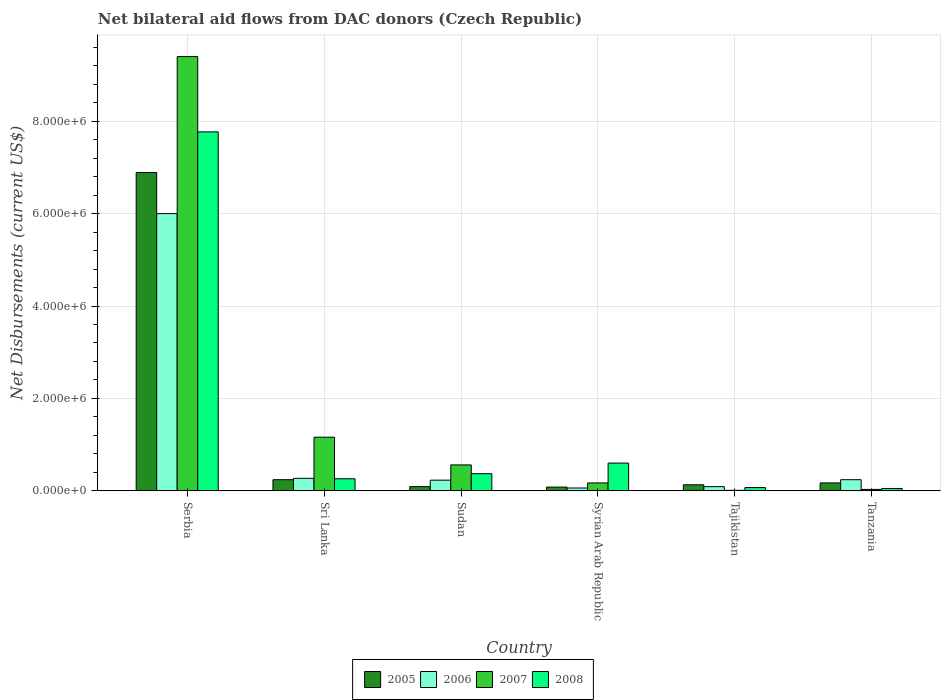Are the number of bars per tick equal to the number of legend labels?
Provide a succinct answer. Yes. How many bars are there on the 1st tick from the left?
Ensure brevity in your answer.  4. What is the label of the 6th group of bars from the left?
Ensure brevity in your answer.  Tanzania. In how many cases, is the number of bars for a given country not equal to the number of legend labels?
Your answer should be compact. 0. What is the net bilateral aid flows in 2005 in Sri Lanka?
Your answer should be very brief. 2.40e+05. In which country was the net bilateral aid flows in 2008 maximum?
Your response must be concise. Serbia. In which country was the net bilateral aid flows in 2006 minimum?
Your answer should be compact. Syrian Arab Republic. What is the total net bilateral aid flows in 2008 in the graph?
Your answer should be very brief. 9.12e+06. What is the difference between the net bilateral aid flows in 2008 in Sri Lanka and that in Tanzania?
Your answer should be very brief. 2.10e+05. What is the average net bilateral aid flows in 2005 per country?
Make the answer very short. 1.27e+06. What is the difference between the net bilateral aid flows of/in 2008 and net bilateral aid flows of/in 2005 in Syrian Arab Republic?
Your answer should be compact. 5.20e+05. Is the net bilateral aid flows in 2008 in Sri Lanka less than that in Syrian Arab Republic?
Make the answer very short. Yes. Is the difference between the net bilateral aid flows in 2008 in Sri Lanka and Tanzania greater than the difference between the net bilateral aid flows in 2005 in Sri Lanka and Tanzania?
Provide a succinct answer. Yes. What is the difference between the highest and the second highest net bilateral aid flows in 2007?
Make the answer very short. 8.24e+06. What is the difference between the highest and the lowest net bilateral aid flows in 2008?
Ensure brevity in your answer.  7.72e+06. Is it the case that in every country, the sum of the net bilateral aid flows in 2005 and net bilateral aid flows in 2007 is greater than the sum of net bilateral aid flows in 2008 and net bilateral aid flows in 2006?
Your answer should be very brief. No. What does the 3rd bar from the left in Sri Lanka represents?
Keep it short and to the point. 2007. What does the 3rd bar from the right in Tanzania represents?
Make the answer very short. 2006. Is it the case that in every country, the sum of the net bilateral aid flows in 2005 and net bilateral aid flows in 2008 is greater than the net bilateral aid flows in 2007?
Provide a short and direct response. No. How many bars are there?
Your response must be concise. 24. How many countries are there in the graph?
Give a very brief answer. 6. Are the values on the major ticks of Y-axis written in scientific E-notation?
Keep it short and to the point. Yes. Where does the legend appear in the graph?
Provide a short and direct response. Bottom center. How many legend labels are there?
Provide a short and direct response. 4. How are the legend labels stacked?
Provide a succinct answer. Horizontal. What is the title of the graph?
Offer a terse response. Net bilateral aid flows from DAC donors (Czech Republic). What is the label or title of the X-axis?
Offer a very short reply. Country. What is the label or title of the Y-axis?
Your answer should be compact. Net Disbursements (current US$). What is the Net Disbursements (current US$) of 2005 in Serbia?
Your answer should be very brief. 6.89e+06. What is the Net Disbursements (current US$) in 2006 in Serbia?
Ensure brevity in your answer.  6.00e+06. What is the Net Disbursements (current US$) in 2007 in Serbia?
Offer a very short reply. 9.40e+06. What is the Net Disbursements (current US$) of 2008 in Serbia?
Make the answer very short. 7.77e+06. What is the Net Disbursements (current US$) in 2005 in Sri Lanka?
Give a very brief answer. 2.40e+05. What is the Net Disbursements (current US$) in 2007 in Sri Lanka?
Provide a short and direct response. 1.16e+06. What is the Net Disbursements (current US$) of 2008 in Sri Lanka?
Ensure brevity in your answer.  2.60e+05. What is the Net Disbursements (current US$) in 2005 in Sudan?
Your answer should be very brief. 9.00e+04. What is the Net Disbursements (current US$) in 2007 in Sudan?
Your response must be concise. 5.60e+05. What is the Net Disbursements (current US$) of 2008 in Syrian Arab Republic?
Your response must be concise. 6.00e+05. What is the Net Disbursements (current US$) of 2006 in Tajikistan?
Give a very brief answer. 9.00e+04. What is the Net Disbursements (current US$) of 2007 in Tajikistan?
Provide a succinct answer. 10000. What is the Net Disbursements (current US$) of 2008 in Tajikistan?
Your answer should be compact. 7.00e+04. What is the Net Disbursements (current US$) of 2005 in Tanzania?
Your answer should be very brief. 1.70e+05. What is the Net Disbursements (current US$) of 2007 in Tanzania?
Offer a terse response. 3.00e+04. What is the Net Disbursements (current US$) of 2008 in Tanzania?
Your answer should be compact. 5.00e+04. Across all countries, what is the maximum Net Disbursements (current US$) in 2005?
Ensure brevity in your answer.  6.89e+06. Across all countries, what is the maximum Net Disbursements (current US$) of 2007?
Offer a very short reply. 9.40e+06. Across all countries, what is the maximum Net Disbursements (current US$) in 2008?
Your answer should be compact. 7.77e+06. Across all countries, what is the minimum Net Disbursements (current US$) in 2005?
Ensure brevity in your answer.  8.00e+04. What is the total Net Disbursements (current US$) of 2005 in the graph?
Provide a short and direct response. 7.60e+06. What is the total Net Disbursements (current US$) in 2006 in the graph?
Ensure brevity in your answer.  6.89e+06. What is the total Net Disbursements (current US$) of 2007 in the graph?
Keep it short and to the point. 1.13e+07. What is the total Net Disbursements (current US$) of 2008 in the graph?
Offer a very short reply. 9.12e+06. What is the difference between the Net Disbursements (current US$) in 2005 in Serbia and that in Sri Lanka?
Offer a very short reply. 6.65e+06. What is the difference between the Net Disbursements (current US$) in 2006 in Serbia and that in Sri Lanka?
Provide a succinct answer. 5.73e+06. What is the difference between the Net Disbursements (current US$) of 2007 in Serbia and that in Sri Lanka?
Keep it short and to the point. 8.24e+06. What is the difference between the Net Disbursements (current US$) in 2008 in Serbia and that in Sri Lanka?
Provide a succinct answer. 7.51e+06. What is the difference between the Net Disbursements (current US$) of 2005 in Serbia and that in Sudan?
Keep it short and to the point. 6.80e+06. What is the difference between the Net Disbursements (current US$) of 2006 in Serbia and that in Sudan?
Your answer should be compact. 5.77e+06. What is the difference between the Net Disbursements (current US$) of 2007 in Serbia and that in Sudan?
Ensure brevity in your answer.  8.84e+06. What is the difference between the Net Disbursements (current US$) in 2008 in Serbia and that in Sudan?
Provide a succinct answer. 7.40e+06. What is the difference between the Net Disbursements (current US$) in 2005 in Serbia and that in Syrian Arab Republic?
Your answer should be compact. 6.81e+06. What is the difference between the Net Disbursements (current US$) in 2006 in Serbia and that in Syrian Arab Republic?
Provide a short and direct response. 5.94e+06. What is the difference between the Net Disbursements (current US$) of 2007 in Serbia and that in Syrian Arab Republic?
Ensure brevity in your answer.  9.23e+06. What is the difference between the Net Disbursements (current US$) in 2008 in Serbia and that in Syrian Arab Republic?
Provide a short and direct response. 7.17e+06. What is the difference between the Net Disbursements (current US$) in 2005 in Serbia and that in Tajikistan?
Give a very brief answer. 6.76e+06. What is the difference between the Net Disbursements (current US$) in 2006 in Serbia and that in Tajikistan?
Your response must be concise. 5.91e+06. What is the difference between the Net Disbursements (current US$) of 2007 in Serbia and that in Tajikistan?
Offer a very short reply. 9.39e+06. What is the difference between the Net Disbursements (current US$) of 2008 in Serbia and that in Tajikistan?
Keep it short and to the point. 7.70e+06. What is the difference between the Net Disbursements (current US$) in 2005 in Serbia and that in Tanzania?
Offer a very short reply. 6.72e+06. What is the difference between the Net Disbursements (current US$) in 2006 in Serbia and that in Tanzania?
Your answer should be compact. 5.76e+06. What is the difference between the Net Disbursements (current US$) in 2007 in Serbia and that in Tanzania?
Provide a succinct answer. 9.37e+06. What is the difference between the Net Disbursements (current US$) in 2008 in Serbia and that in Tanzania?
Offer a terse response. 7.72e+06. What is the difference between the Net Disbursements (current US$) of 2006 in Sri Lanka and that in Sudan?
Make the answer very short. 4.00e+04. What is the difference between the Net Disbursements (current US$) in 2007 in Sri Lanka and that in Sudan?
Your answer should be very brief. 6.00e+05. What is the difference between the Net Disbursements (current US$) of 2005 in Sri Lanka and that in Syrian Arab Republic?
Provide a short and direct response. 1.60e+05. What is the difference between the Net Disbursements (current US$) of 2007 in Sri Lanka and that in Syrian Arab Republic?
Give a very brief answer. 9.90e+05. What is the difference between the Net Disbursements (current US$) in 2008 in Sri Lanka and that in Syrian Arab Republic?
Offer a terse response. -3.40e+05. What is the difference between the Net Disbursements (current US$) in 2007 in Sri Lanka and that in Tajikistan?
Offer a terse response. 1.15e+06. What is the difference between the Net Disbursements (current US$) of 2006 in Sri Lanka and that in Tanzania?
Your answer should be compact. 3.00e+04. What is the difference between the Net Disbursements (current US$) in 2007 in Sri Lanka and that in Tanzania?
Keep it short and to the point. 1.13e+06. What is the difference between the Net Disbursements (current US$) of 2007 in Sudan and that in Syrian Arab Republic?
Provide a succinct answer. 3.90e+05. What is the difference between the Net Disbursements (current US$) of 2006 in Sudan and that in Tajikistan?
Provide a succinct answer. 1.40e+05. What is the difference between the Net Disbursements (current US$) of 2007 in Sudan and that in Tajikistan?
Your answer should be compact. 5.50e+05. What is the difference between the Net Disbursements (current US$) of 2008 in Sudan and that in Tajikistan?
Offer a terse response. 3.00e+05. What is the difference between the Net Disbursements (current US$) of 2005 in Sudan and that in Tanzania?
Offer a very short reply. -8.00e+04. What is the difference between the Net Disbursements (current US$) of 2006 in Sudan and that in Tanzania?
Keep it short and to the point. -10000. What is the difference between the Net Disbursements (current US$) in 2007 in Sudan and that in Tanzania?
Provide a short and direct response. 5.30e+05. What is the difference between the Net Disbursements (current US$) of 2005 in Syrian Arab Republic and that in Tajikistan?
Your response must be concise. -5.00e+04. What is the difference between the Net Disbursements (current US$) in 2006 in Syrian Arab Republic and that in Tajikistan?
Your response must be concise. -3.00e+04. What is the difference between the Net Disbursements (current US$) in 2007 in Syrian Arab Republic and that in Tajikistan?
Your response must be concise. 1.60e+05. What is the difference between the Net Disbursements (current US$) in 2008 in Syrian Arab Republic and that in Tajikistan?
Ensure brevity in your answer.  5.30e+05. What is the difference between the Net Disbursements (current US$) in 2006 in Syrian Arab Republic and that in Tanzania?
Your answer should be compact. -1.80e+05. What is the difference between the Net Disbursements (current US$) of 2007 in Syrian Arab Republic and that in Tanzania?
Your response must be concise. 1.40e+05. What is the difference between the Net Disbursements (current US$) of 2005 in Tajikistan and that in Tanzania?
Offer a very short reply. -4.00e+04. What is the difference between the Net Disbursements (current US$) in 2008 in Tajikistan and that in Tanzania?
Your response must be concise. 2.00e+04. What is the difference between the Net Disbursements (current US$) of 2005 in Serbia and the Net Disbursements (current US$) of 2006 in Sri Lanka?
Ensure brevity in your answer.  6.62e+06. What is the difference between the Net Disbursements (current US$) of 2005 in Serbia and the Net Disbursements (current US$) of 2007 in Sri Lanka?
Your response must be concise. 5.73e+06. What is the difference between the Net Disbursements (current US$) in 2005 in Serbia and the Net Disbursements (current US$) in 2008 in Sri Lanka?
Offer a very short reply. 6.63e+06. What is the difference between the Net Disbursements (current US$) in 2006 in Serbia and the Net Disbursements (current US$) in 2007 in Sri Lanka?
Offer a terse response. 4.84e+06. What is the difference between the Net Disbursements (current US$) of 2006 in Serbia and the Net Disbursements (current US$) of 2008 in Sri Lanka?
Offer a very short reply. 5.74e+06. What is the difference between the Net Disbursements (current US$) of 2007 in Serbia and the Net Disbursements (current US$) of 2008 in Sri Lanka?
Offer a terse response. 9.14e+06. What is the difference between the Net Disbursements (current US$) in 2005 in Serbia and the Net Disbursements (current US$) in 2006 in Sudan?
Your answer should be compact. 6.66e+06. What is the difference between the Net Disbursements (current US$) in 2005 in Serbia and the Net Disbursements (current US$) in 2007 in Sudan?
Ensure brevity in your answer.  6.33e+06. What is the difference between the Net Disbursements (current US$) of 2005 in Serbia and the Net Disbursements (current US$) of 2008 in Sudan?
Your answer should be compact. 6.52e+06. What is the difference between the Net Disbursements (current US$) in 2006 in Serbia and the Net Disbursements (current US$) in 2007 in Sudan?
Provide a short and direct response. 5.44e+06. What is the difference between the Net Disbursements (current US$) of 2006 in Serbia and the Net Disbursements (current US$) of 2008 in Sudan?
Offer a very short reply. 5.63e+06. What is the difference between the Net Disbursements (current US$) of 2007 in Serbia and the Net Disbursements (current US$) of 2008 in Sudan?
Ensure brevity in your answer.  9.03e+06. What is the difference between the Net Disbursements (current US$) in 2005 in Serbia and the Net Disbursements (current US$) in 2006 in Syrian Arab Republic?
Make the answer very short. 6.83e+06. What is the difference between the Net Disbursements (current US$) of 2005 in Serbia and the Net Disbursements (current US$) of 2007 in Syrian Arab Republic?
Your answer should be compact. 6.72e+06. What is the difference between the Net Disbursements (current US$) in 2005 in Serbia and the Net Disbursements (current US$) in 2008 in Syrian Arab Republic?
Keep it short and to the point. 6.29e+06. What is the difference between the Net Disbursements (current US$) in 2006 in Serbia and the Net Disbursements (current US$) in 2007 in Syrian Arab Republic?
Ensure brevity in your answer.  5.83e+06. What is the difference between the Net Disbursements (current US$) of 2006 in Serbia and the Net Disbursements (current US$) of 2008 in Syrian Arab Republic?
Provide a short and direct response. 5.40e+06. What is the difference between the Net Disbursements (current US$) in 2007 in Serbia and the Net Disbursements (current US$) in 2008 in Syrian Arab Republic?
Provide a succinct answer. 8.80e+06. What is the difference between the Net Disbursements (current US$) of 2005 in Serbia and the Net Disbursements (current US$) of 2006 in Tajikistan?
Your answer should be very brief. 6.80e+06. What is the difference between the Net Disbursements (current US$) in 2005 in Serbia and the Net Disbursements (current US$) in 2007 in Tajikistan?
Offer a very short reply. 6.88e+06. What is the difference between the Net Disbursements (current US$) in 2005 in Serbia and the Net Disbursements (current US$) in 2008 in Tajikistan?
Make the answer very short. 6.82e+06. What is the difference between the Net Disbursements (current US$) in 2006 in Serbia and the Net Disbursements (current US$) in 2007 in Tajikistan?
Provide a succinct answer. 5.99e+06. What is the difference between the Net Disbursements (current US$) in 2006 in Serbia and the Net Disbursements (current US$) in 2008 in Tajikistan?
Your response must be concise. 5.93e+06. What is the difference between the Net Disbursements (current US$) of 2007 in Serbia and the Net Disbursements (current US$) of 2008 in Tajikistan?
Keep it short and to the point. 9.33e+06. What is the difference between the Net Disbursements (current US$) of 2005 in Serbia and the Net Disbursements (current US$) of 2006 in Tanzania?
Give a very brief answer. 6.65e+06. What is the difference between the Net Disbursements (current US$) of 2005 in Serbia and the Net Disbursements (current US$) of 2007 in Tanzania?
Your answer should be very brief. 6.86e+06. What is the difference between the Net Disbursements (current US$) of 2005 in Serbia and the Net Disbursements (current US$) of 2008 in Tanzania?
Keep it short and to the point. 6.84e+06. What is the difference between the Net Disbursements (current US$) in 2006 in Serbia and the Net Disbursements (current US$) in 2007 in Tanzania?
Give a very brief answer. 5.97e+06. What is the difference between the Net Disbursements (current US$) of 2006 in Serbia and the Net Disbursements (current US$) of 2008 in Tanzania?
Keep it short and to the point. 5.95e+06. What is the difference between the Net Disbursements (current US$) of 2007 in Serbia and the Net Disbursements (current US$) of 2008 in Tanzania?
Your response must be concise. 9.35e+06. What is the difference between the Net Disbursements (current US$) in 2005 in Sri Lanka and the Net Disbursements (current US$) in 2007 in Sudan?
Provide a short and direct response. -3.20e+05. What is the difference between the Net Disbursements (current US$) of 2006 in Sri Lanka and the Net Disbursements (current US$) of 2007 in Sudan?
Offer a very short reply. -2.90e+05. What is the difference between the Net Disbursements (current US$) of 2006 in Sri Lanka and the Net Disbursements (current US$) of 2008 in Sudan?
Ensure brevity in your answer.  -1.00e+05. What is the difference between the Net Disbursements (current US$) in 2007 in Sri Lanka and the Net Disbursements (current US$) in 2008 in Sudan?
Your response must be concise. 7.90e+05. What is the difference between the Net Disbursements (current US$) in 2005 in Sri Lanka and the Net Disbursements (current US$) in 2006 in Syrian Arab Republic?
Provide a short and direct response. 1.80e+05. What is the difference between the Net Disbursements (current US$) of 2005 in Sri Lanka and the Net Disbursements (current US$) of 2007 in Syrian Arab Republic?
Keep it short and to the point. 7.00e+04. What is the difference between the Net Disbursements (current US$) of 2005 in Sri Lanka and the Net Disbursements (current US$) of 2008 in Syrian Arab Republic?
Keep it short and to the point. -3.60e+05. What is the difference between the Net Disbursements (current US$) in 2006 in Sri Lanka and the Net Disbursements (current US$) in 2008 in Syrian Arab Republic?
Provide a succinct answer. -3.30e+05. What is the difference between the Net Disbursements (current US$) in 2007 in Sri Lanka and the Net Disbursements (current US$) in 2008 in Syrian Arab Republic?
Make the answer very short. 5.60e+05. What is the difference between the Net Disbursements (current US$) of 2005 in Sri Lanka and the Net Disbursements (current US$) of 2006 in Tajikistan?
Keep it short and to the point. 1.50e+05. What is the difference between the Net Disbursements (current US$) of 2005 in Sri Lanka and the Net Disbursements (current US$) of 2007 in Tajikistan?
Your response must be concise. 2.30e+05. What is the difference between the Net Disbursements (current US$) of 2005 in Sri Lanka and the Net Disbursements (current US$) of 2008 in Tajikistan?
Your answer should be very brief. 1.70e+05. What is the difference between the Net Disbursements (current US$) of 2007 in Sri Lanka and the Net Disbursements (current US$) of 2008 in Tajikistan?
Ensure brevity in your answer.  1.09e+06. What is the difference between the Net Disbursements (current US$) of 2006 in Sri Lanka and the Net Disbursements (current US$) of 2008 in Tanzania?
Give a very brief answer. 2.20e+05. What is the difference between the Net Disbursements (current US$) of 2007 in Sri Lanka and the Net Disbursements (current US$) of 2008 in Tanzania?
Keep it short and to the point. 1.11e+06. What is the difference between the Net Disbursements (current US$) of 2005 in Sudan and the Net Disbursements (current US$) of 2006 in Syrian Arab Republic?
Make the answer very short. 3.00e+04. What is the difference between the Net Disbursements (current US$) in 2005 in Sudan and the Net Disbursements (current US$) in 2008 in Syrian Arab Republic?
Make the answer very short. -5.10e+05. What is the difference between the Net Disbursements (current US$) of 2006 in Sudan and the Net Disbursements (current US$) of 2007 in Syrian Arab Republic?
Provide a short and direct response. 6.00e+04. What is the difference between the Net Disbursements (current US$) of 2006 in Sudan and the Net Disbursements (current US$) of 2008 in Syrian Arab Republic?
Ensure brevity in your answer.  -3.70e+05. What is the difference between the Net Disbursements (current US$) in 2007 in Sudan and the Net Disbursements (current US$) in 2008 in Syrian Arab Republic?
Keep it short and to the point. -4.00e+04. What is the difference between the Net Disbursements (current US$) of 2005 in Sudan and the Net Disbursements (current US$) of 2007 in Tajikistan?
Offer a terse response. 8.00e+04. What is the difference between the Net Disbursements (current US$) of 2005 in Sudan and the Net Disbursements (current US$) of 2008 in Tajikistan?
Give a very brief answer. 2.00e+04. What is the difference between the Net Disbursements (current US$) in 2006 in Sudan and the Net Disbursements (current US$) in 2007 in Tajikistan?
Offer a very short reply. 2.20e+05. What is the difference between the Net Disbursements (current US$) of 2007 in Sudan and the Net Disbursements (current US$) of 2008 in Tajikistan?
Your answer should be very brief. 4.90e+05. What is the difference between the Net Disbursements (current US$) of 2005 in Sudan and the Net Disbursements (current US$) of 2007 in Tanzania?
Offer a terse response. 6.00e+04. What is the difference between the Net Disbursements (current US$) in 2005 in Sudan and the Net Disbursements (current US$) in 2008 in Tanzania?
Provide a succinct answer. 4.00e+04. What is the difference between the Net Disbursements (current US$) of 2006 in Sudan and the Net Disbursements (current US$) of 2007 in Tanzania?
Provide a succinct answer. 2.00e+05. What is the difference between the Net Disbursements (current US$) of 2006 in Sudan and the Net Disbursements (current US$) of 2008 in Tanzania?
Your response must be concise. 1.80e+05. What is the difference between the Net Disbursements (current US$) of 2007 in Sudan and the Net Disbursements (current US$) of 2008 in Tanzania?
Offer a terse response. 5.10e+05. What is the difference between the Net Disbursements (current US$) of 2005 in Syrian Arab Republic and the Net Disbursements (current US$) of 2007 in Tajikistan?
Offer a terse response. 7.00e+04. What is the difference between the Net Disbursements (current US$) in 2005 in Syrian Arab Republic and the Net Disbursements (current US$) in 2008 in Tajikistan?
Provide a short and direct response. 10000. What is the difference between the Net Disbursements (current US$) of 2006 in Syrian Arab Republic and the Net Disbursements (current US$) of 2007 in Tajikistan?
Your response must be concise. 5.00e+04. What is the difference between the Net Disbursements (current US$) in 2005 in Syrian Arab Republic and the Net Disbursements (current US$) in 2006 in Tanzania?
Make the answer very short. -1.60e+05. What is the difference between the Net Disbursements (current US$) in 2005 in Syrian Arab Republic and the Net Disbursements (current US$) in 2008 in Tanzania?
Your answer should be very brief. 3.00e+04. What is the difference between the Net Disbursements (current US$) of 2006 in Syrian Arab Republic and the Net Disbursements (current US$) of 2007 in Tanzania?
Keep it short and to the point. 3.00e+04. What is the difference between the Net Disbursements (current US$) of 2006 in Syrian Arab Republic and the Net Disbursements (current US$) of 2008 in Tanzania?
Keep it short and to the point. 10000. What is the difference between the Net Disbursements (current US$) of 2005 in Tajikistan and the Net Disbursements (current US$) of 2008 in Tanzania?
Provide a short and direct response. 8.00e+04. What is the difference between the Net Disbursements (current US$) of 2006 in Tajikistan and the Net Disbursements (current US$) of 2007 in Tanzania?
Offer a terse response. 6.00e+04. What is the average Net Disbursements (current US$) of 2005 per country?
Give a very brief answer. 1.27e+06. What is the average Net Disbursements (current US$) in 2006 per country?
Your answer should be very brief. 1.15e+06. What is the average Net Disbursements (current US$) in 2007 per country?
Give a very brief answer. 1.89e+06. What is the average Net Disbursements (current US$) in 2008 per country?
Your answer should be compact. 1.52e+06. What is the difference between the Net Disbursements (current US$) of 2005 and Net Disbursements (current US$) of 2006 in Serbia?
Offer a terse response. 8.90e+05. What is the difference between the Net Disbursements (current US$) in 2005 and Net Disbursements (current US$) in 2007 in Serbia?
Provide a succinct answer. -2.51e+06. What is the difference between the Net Disbursements (current US$) in 2005 and Net Disbursements (current US$) in 2008 in Serbia?
Give a very brief answer. -8.80e+05. What is the difference between the Net Disbursements (current US$) in 2006 and Net Disbursements (current US$) in 2007 in Serbia?
Ensure brevity in your answer.  -3.40e+06. What is the difference between the Net Disbursements (current US$) in 2006 and Net Disbursements (current US$) in 2008 in Serbia?
Offer a very short reply. -1.77e+06. What is the difference between the Net Disbursements (current US$) of 2007 and Net Disbursements (current US$) of 2008 in Serbia?
Provide a short and direct response. 1.63e+06. What is the difference between the Net Disbursements (current US$) of 2005 and Net Disbursements (current US$) of 2006 in Sri Lanka?
Provide a succinct answer. -3.00e+04. What is the difference between the Net Disbursements (current US$) of 2005 and Net Disbursements (current US$) of 2007 in Sri Lanka?
Your answer should be very brief. -9.20e+05. What is the difference between the Net Disbursements (current US$) of 2005 and Net Disbursements (current US$) of 2008 in Sri Lanka?
Make the answer very short. -2.00e+04. What is the difference between the Net Disbursements (current US$) of 2006 and Net Disbursements (current US$) of 2007 in Sri Lanka?
Your answer should be compact. -8.90e+05. What is the difference between the Net Disbursements (current US$) in 2005 and Net Disbursements (current US$) in 2006 in Sudan?
Provide a short and direct response. -1.40e+05. What is the difference between the Net Disbursements (current US$) in 2005 and Net Disbursements (current US$) in 2007 in Sudan?
Make the answer very short. -4.70e+05. What is the difference between the Net Disbursements (current US$) in 2005 and Net Disbursements (current US$) in 2008 in Sudan?
Ensure brevity in your answer.  -2.80e+05. What is the difference between the Net Disbursements (current US$) in 2006 and Net Disbursements (current US$) in 2007 in Sudan?
Give a very brief answer. -3.30e+05. What is the difference between the Net Disbursements (current US$) in 2005 and Net Disbursements (current US$) in 2006 in Syrian Arab Republic?
Give a very brief answer. 2.00e+04. What is the difference between the Net Disbursements (current US$) in 2005 and Net Disbursements (current US$) in 2007 in Syrian Arab Republic?
Your answer should be very brief. -9.00e+04. What is the difference between the Net Disbursements (current US$) in 2005 and Net Disbursements (current US$) in 2008 in Syrian Arab Republic?
Keep it short and to the point. -5.20e+05. What is the difference between the Net Disbursements (current US$) in 2006 and Net Disbursements (current US$) in 2008 in Syrian Arab Republic?
Your response must be concise. -5.40e+05. What is the difference between the Net Disbursements (current US$) in 2007 and Net Disbursements (current US$) in 2008 in Syrian Arab Republic?
Keep it short and to the point. -4.30e+05. What is the difference between the Net Disbursements (current US$) in 2005 and Net Disbursements (current US$) in 2007 in Tajikistan?
Offer a terse response. 1.20e+05. What is the difference between the Net Disbursements (current US$) of 2005 and Net Disbursements (current US$) of 2008 in Tajikistan?
Give a very brief answer. 6.00e+04. What is the difference between the Net Disbursements (current US$) of 2006 and Net Disbursements (current US$) of 2007 in Tajikistan?
Give a very brief answer. 8.00e+04. What is the difference between the Net Disbursements (current US$) in 2007 and Net Disbursements (current US$) in 2008 in Tajikistan?
Provide a succinct answer. -6.00e+04. What is the difference between the Net Disbursements (current US$) in 2006 and Net Disbursements (current US$) in 2007 in Tanzania?
Offer a very short reply. 2.10e+05. What is the ratio of the Net Disbursements (current US$) of 2005 in Serbia to that in Sri Lanka?
Offer a very short reply. 28.71. What is the ratio of the Net Disbursements (current US$) in 2006 in Serbia to that in Sri Lanka?
Give a very brief answer. 22.22. What is the ratio of the Net Disbursements (current US$) of 2007 in Serbia to that in Sri Lanka?
Offer a very short reply. 8.1. What is the ratio of the Net Disbursements (current US$) in 2008 in Serbia to that in Sri Lanka?
Your answer should be very brief. 29.88. What is the ratio of the Net Disbursements (current US$) in 2005 in Serbia to that in Sudan?
Provide a succinct answer. 76.56. What is the ratio of the Net Disbursements (current US$) of 2006 in Serbia to that in Sudan?
Ensure brevity in your answer.  26.09. What is the ratio of the Net Disbursements (current US$) of 2007 in Serbia to that in Sudan?
Give a very brief answer. 16.79. What is the ratio of the Net Disbursements (current US$) of 2008 in Serbia to that in Sudan?
Your answer should be very brief. 21. What is the ratio of the Net Disbursements (current US$) of 2005 in Serbia to that in Syrian Arab Republic?
Provide a succinct answer. 86.12. What is the ratio of the Net Disbursements (current US$) of 2007 in Serbia to that in Syrian Arab Republic?
Offer a terse response. 55.29. What is the ratio of the Net Disbursements (current US$) in 2008 in Serbia to that in Syrian Arab Republic?
Give a very brief answer. 12.95. What is the ratio of the Net Disbursements (current US$) in 2005 in Serbia to that in Tajikistan?
Provide a short and direct response. 53. What is the ratio of the Net Disbursements (current US$) in 2006 in Serbia to that in Tajikistan?
Your answer should be compact. 66.67. What is the ratio of the Net Disbursements (current US$) in 2007 in Serbia to that in Tajikistan?
Your answer should be compact. 940. What is the ratio of the Net Disbursements (current US$) of 2008 in Serbia to that in Tajikistan?
Provide a succinct answer. 111. What is the ratio of the Net Disbursements (current US$) of 2005 in Serbia to that in Tanzania?
Offer a terse response. 40.53. What is the ratio of the Net Disbursements (current US$) in 2007 in Serbia to that in Tanzania?
Your answer should be very brief. 313.33. What is the ratio of the Net Disbursements (current US$) in 2008 in Serbia to that in Tanzania?
Provide a short and direct response. 155.4. What is the ratio of the Net Disbursements (current US$) in 2005 in Sri Lanka to that in Sudan?
Keep it short and to the point. 2.67. What is the ratio of the Net Disbursements (current US$) in 2006 in Sri Lanka to that in Sudan?
Provide a succinct answer. 1.17. What is the ratio of the Net Disbursements (current US$) in 2007 in Sri Lanka to that in Sudan?
Your answer should be compact. 2.07. What is the ratio of the Net Disbursements (current US$) in 2008 in Sri Lanka to that in Sudan?
Give a very brief answer. 0.7. What is the ratio of the Net Disbursements (current US$) of 2005 in Sri Lanka to that in Syrian Arab Republic?
Your answer should be compact. 3. What is the ratio of the Net Disbursements (current US$) of 2006 in Sri Lanka to that in Syrian Arab Republic?
Your answer should be very brief. 4.5. What is the ratio of the Net Disbursements (current US$) in 2007 in Sri Lanka to that in Syrian Arab Republic?
Your answer should be very brief. 6.82. What is the ratio of the Net Disbursements (current US$) in 2008 in Sri Lanka to that in Syrian Arab Republic?
Provide a short and direct response. 0.43. What is the ratio of the Net Disbursements (current US$) in 2005 in Sri Lanka to that in Tajikistan?
Provide a short and direct response. 1.85. What is the ratio of the Net Disbursements (current US$) in 2007 in Sri Lanka to that in Tajikistan?
Offer a very short reply. 116. What is the ratio of the Net Disbursements (current US$) in 2008 in Sri Lanka to that in Tajikistan?
Your answer should be very brief. 3.71. What is the ratio of the Net Disbursements (current US$) in 2005 in Sri Lanka to that in Tanzania?
Provide a short and direct response. 1.41. What is the ratio of the Net Disbursements (current US$) of 2007 in Sri Lanka to that in Tanzania?
Make the answer very short. 38.67. What is the ratio of the Net Disbursements (current US$) of 2005 in Sudan to that in Syrian Arab Republic?
Your answer should be very brief. 1.12. What is the ratio of the Net Disbursements (current US$) in 2006 in Sudan to that in Syrian Arab Republic?
Provide a succinct answer. 3.83. What is the ratio of the Net Disbursements (current US$) of 2007 in Sudan to that in Syrian Arab Republic?
Your answer should be compact. 3.29. What is the ratio of the Net Disbursements (current US$) of 2008 in Sudan to that in Syrian Arab Republic?
Provide a short and direct response. 0.62. What is the ratio of the Net Disbursements (current US$) of 2005 in Sudan to that in Tajikistan?
Provide a short and direct response. 0.69. What is the ratio of the Net Disbursements (current US$) of 2006 in Sudan to that in Tajikistan?
Your answer should be very brief. 2.56. What is the ratio of the Net Disbursements (current US$) in 2008 in Sudan to that in Tajikistan?
Offer a terse response. 5.29. What is the ratio of the Net Disbursements (current US$) in 2005 in Sudan to that in Tanzania?
Offer a very short reply. 0.53. What is the ratio of the Net Disbursements (current US$) of 2007 in Sudan to that in Tanzania?
Make the answer very short. 18.67. What is the ratio of the Net Disbursements (current US$) in 2005 in Syrian Arab Republic to that in Tajikistan?
Offer a terse response. 0.62. What is the ratio of the Net Disbursements (current US$) in 2006 in Syrian Arab Republic to that in Tajikistan?
Ensure brevity in your answer.  0.67. What is the ratio of the Net Disbursements (current US$) of 2008 in Syrian Arab Republic to that in Tajikistan?
Provide a short and direct response. 8.57. What is the ratio of the Net Disbursements (current US$) in 2005 in Syrian Arab Republic to that in Tanzania?
Provide a succinct answer. 0.47. What is the ratio of the Net Disbursements (current US$) of 2006 in Syrian Arab Republic to that in Tanzania?
Ensure brevity in your answer.  0.25. What is the ratio of the Net Disbursements (current US$) in 2007 in Syrian Arab Republic to that in Tanzania?
Your response must be concise. 5.67. What is the ratio of the Net Disbursements (current US$) in 2008 in Syrian Arab Republic to that in Tanzania?
Provide a short and direct response. 12. What is the ratio of the Net Disbursements (current US$) in 2005 in Tajikistan to that in Tanzania?
Offer a very short reply. 0.76. What is the ratio of the Net Disbursements (current US$) of 2006 in Tajikistan to that in Tanzania?
Provide a short and direct response. 0.38. What is the ratio of the Net Disbursements (current US$) in 2007 in Tajikistan to that in Tanzania?
Your answer should be compact. 0.33. What is the ratio of the Net Disbursements (current US$) of 2008 in Tajikistan to that in Tanzania?
Give a very brief answer. 1.4. What is the difference between the highest and the second highest Net Disbursements (current US$) in 2005?
Your answer should be compact. 6.65e+06. What is the difference between the highest and the second highest Net Disbursements (current US$) of 2006?
Your answer should be compact. 5.73e+06. What is the difference between the highest and the second highest Net Disbursements (current US$) in 2007?
Provide a succinct answer. 8.24e+06. What is the difference between the highest and the second highest Net Disbursements (current US$) in 2008?
Your response must be concise. 7.17e+06. What is the difference between the highest and the lowest Net Disbursements (current US$) of 2005?
Keep it short and to the point. 6.81e+06. What is the difference between the highest and the lowest Net Disbursements (current US$) of 2006?
Provide a succinct answer. 5.94e+06. What is the difference between the highest and the lowest Net Disbursements (current US$) of 2007?
Provide a succinct answer. 9.39e+06. What is the difference between the highest and the lowest Net Disbursements (current US$) of 2008?
Offer a terse response. 7.72e+06. 